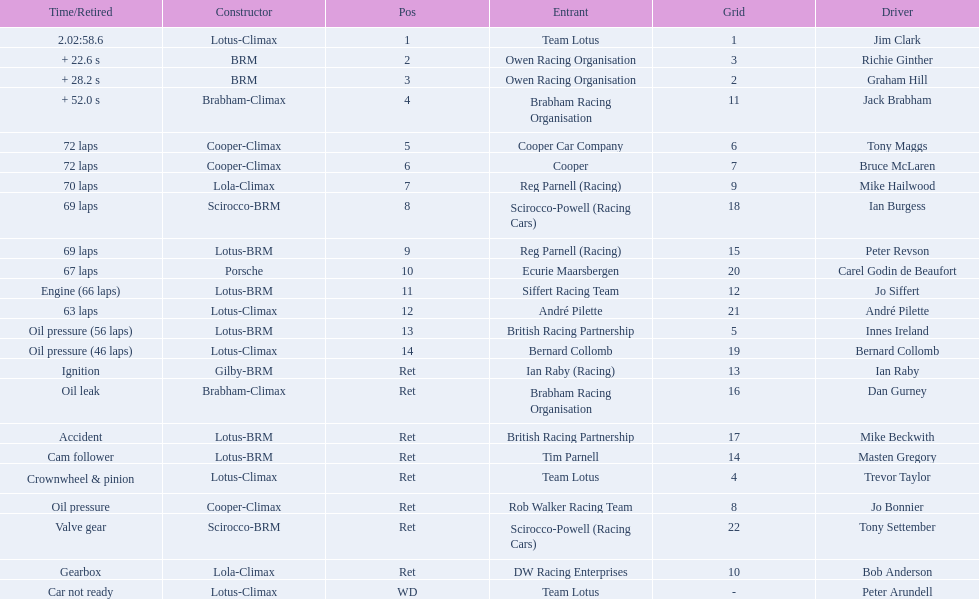Who all drive cars that were constructed bur climax? Jim Clark, Jack Brabham, Tony Maggs, Bruce McLaren, Mike Hailwood, André Pilette, Bernard Collomb, Dan Gurney, Trevor Taylor, Jo Bonnier, Bob Anderson, Peter Arundell. Which driver's climax constructed cars started in the top 10 on the grid? Jim Clark, Tony Maggs, Bruce McLaren, Mike Hailwood, Jo Bonnier, Bob Anderson. Of the top 10 starting climax constructed drivers, which ones did not finish the race? Jo Bonnier, Bob Anderson. What was the failure that was engine related that took out the driver of the climax constructed car that did not finish even though it started in the top 10? Oil pressure. 